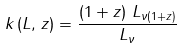<formula> <loc_0><loc_0><loc_500><loc_500>k \left ( L , \, z \right ) = \frac { \left ( 1 + z \right ) \, L _ { \nu ( 1 + z ) } } { L _ { \nu } }</formula> 